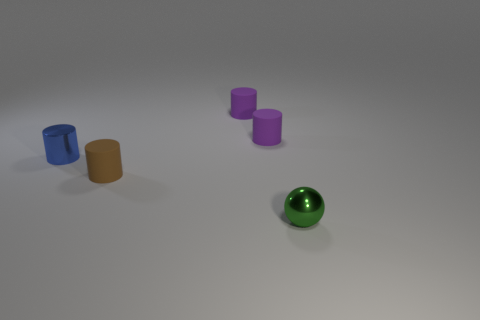Subtract all brown cylinders. How many cylinders are left? 3 Subtract all brown cylinders. How many cylinders are left? 3 Subtract all cylinders. How many objects are left? 1 Add 2 large purple things. How many objects exist? 7 Subtract 1 balls. How many balls are left? 0 Add 3 small green objects. How many small green objects are left? 4 Add 3 large red metallic things. How many large red metallic things exist? 3 Subtract 0 gray cylinders. How many objects are left? 5 Subtract all gray cylinders. Subtract all cyan cubes. How many cylinders are left? 4 Subtract all brown cubes. How many purple cylinders are left? 2 